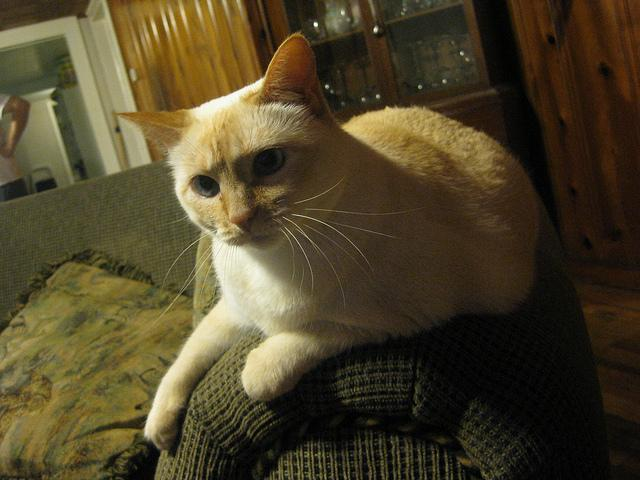What type of cat is this?

Choices:
A) long hair
B) siamese
C) short hair
D) sphynx short hair 